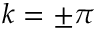Convert formula to latex. <formula><loc_0><loc_0><loc_500><loc_500>k = \pm \pi</formula> 